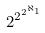Convert formula to latex. <formula><loc_0><loc_0><loc_500><loc_500>2 ^ { 2 ^ { 2 ^ { \aleph _ { 1 } } } }</formula> 